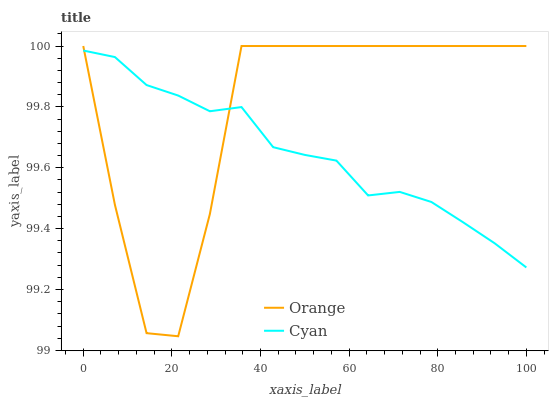Does Cyan have the minimum area under the curve?
Answer yes or no. Yes. Does Orange have the maximum area under the curve?
Answer yes or no. Yes. Does Cyan have the maximum area under the curve?
Answer yes or no. No. Is Cyan the smoothest?
Answer yes or no. Yes. Is Orange the roughest?
Answer yes or no. Yes. Is Cyan the roughest?
Answer yes or no. No. Does Orange have the lowest value?
Answer yes or no. Yes. Does Cyan have the lowest value?
Answer yes or no. No. Does Orange have the highest value?
Answer yes or no. Yes. Does Cyan have the highest value?
Answer yes or no. No. Does Orange intersect Cyan?
Answer yes or no. Yes. Is Orange less than Cyan?
Answer yes or no. No. Is Orange greater than Cyan?
Answer yes or no. No. 